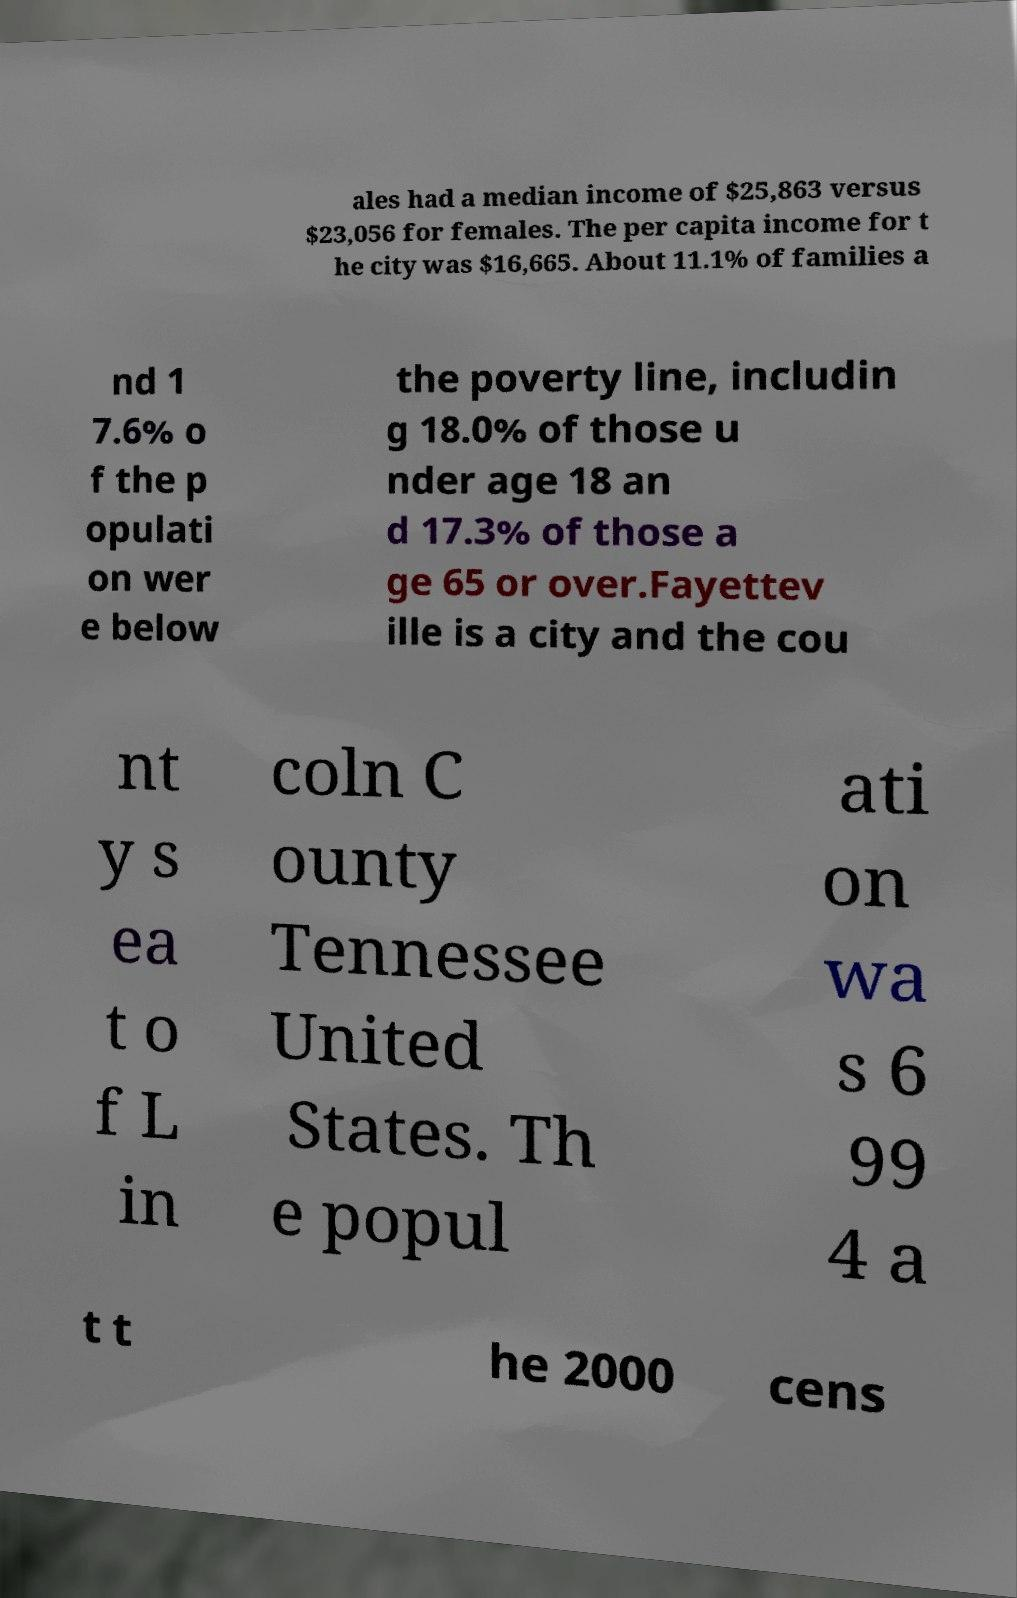What messages or text are displayed in this image? I need them in a readable, typed format. ales had a median income of $25,863 versus $23,056 for females. The per capita income for t he city was $16,665. About 11.1% of families a nd 1 7.6% o f the p opulati on wer e below the poverty line, includin g 18.0% of those u nder age 18 an d 17.3% of those a ge 65 or over.Fayettev ille is a city and the cou nt y s ea t o f L in coln C ounty Tennessee United States. Th e popul ati on wa s 6 99 4 a t t he 2000 cens 